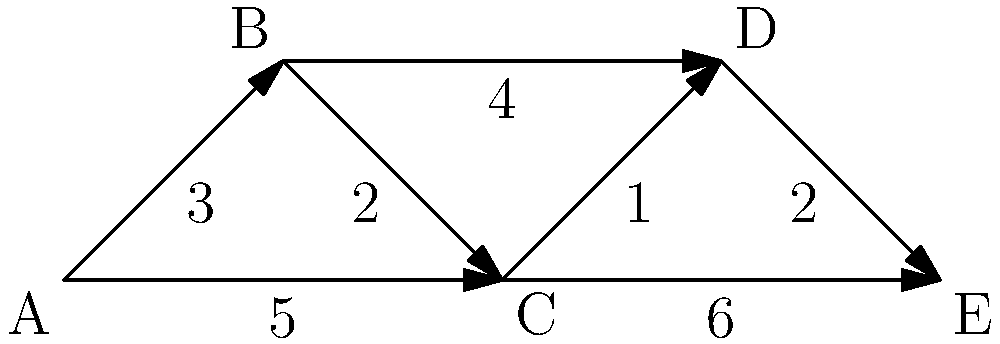In a network of support groups and treatment centers, each node represents a facility, and the edges represent the travel time (in hours) between them. What is the shortest time required to visit all facilities, starting from facility A and ending at facility E? To find the shortest path visiting all facilities from A to E, we need to use the concept of the shortest path algorithm in graph theory. Let's approach this step-by-step:

1) First, we need to identify all possible paths from A to E that visit all facilities:
   A → B → C → D → E
   A → B → D → C → E
   A → C → B → D → E
   A → C → D → B → E

2) Now, let's calculate the total time for each path:

   Path 1 (A → B → C → D → E):
   A to B: 3
   B to C: 2
   C to D: 1
   D to E: 2
   Total: 3 + 2 + 1 + 2 = 8 hours

   Path 2 (A → B → D → C → E):
   A to B: 3
   B to D: 4
   D to C: 1
   C to E: 6
   Total: 3 + 4 + 1 + 6 = 14 hours

   Path 3 (A → C → B → D → E):
   A to C: 5
   C to B: 2
   B to D: 4
   D to E: 2
   Total: 5 + 2 + 4 + 2 = 13 hours

   Path 4 (A → C → D → B → E):
   A to C: 5
   C to D: 1
   D to B: 4
   B to E: No direct path, invalid

3) Comparing the valid paths, we can see that Path 1 (A → B → C → D → E) has the shortest total time of 8 hours.

Therefore, the shortest time required to visit all facilities, starting from A and ending at E, is 8 hours.
Answer: 8 hours 